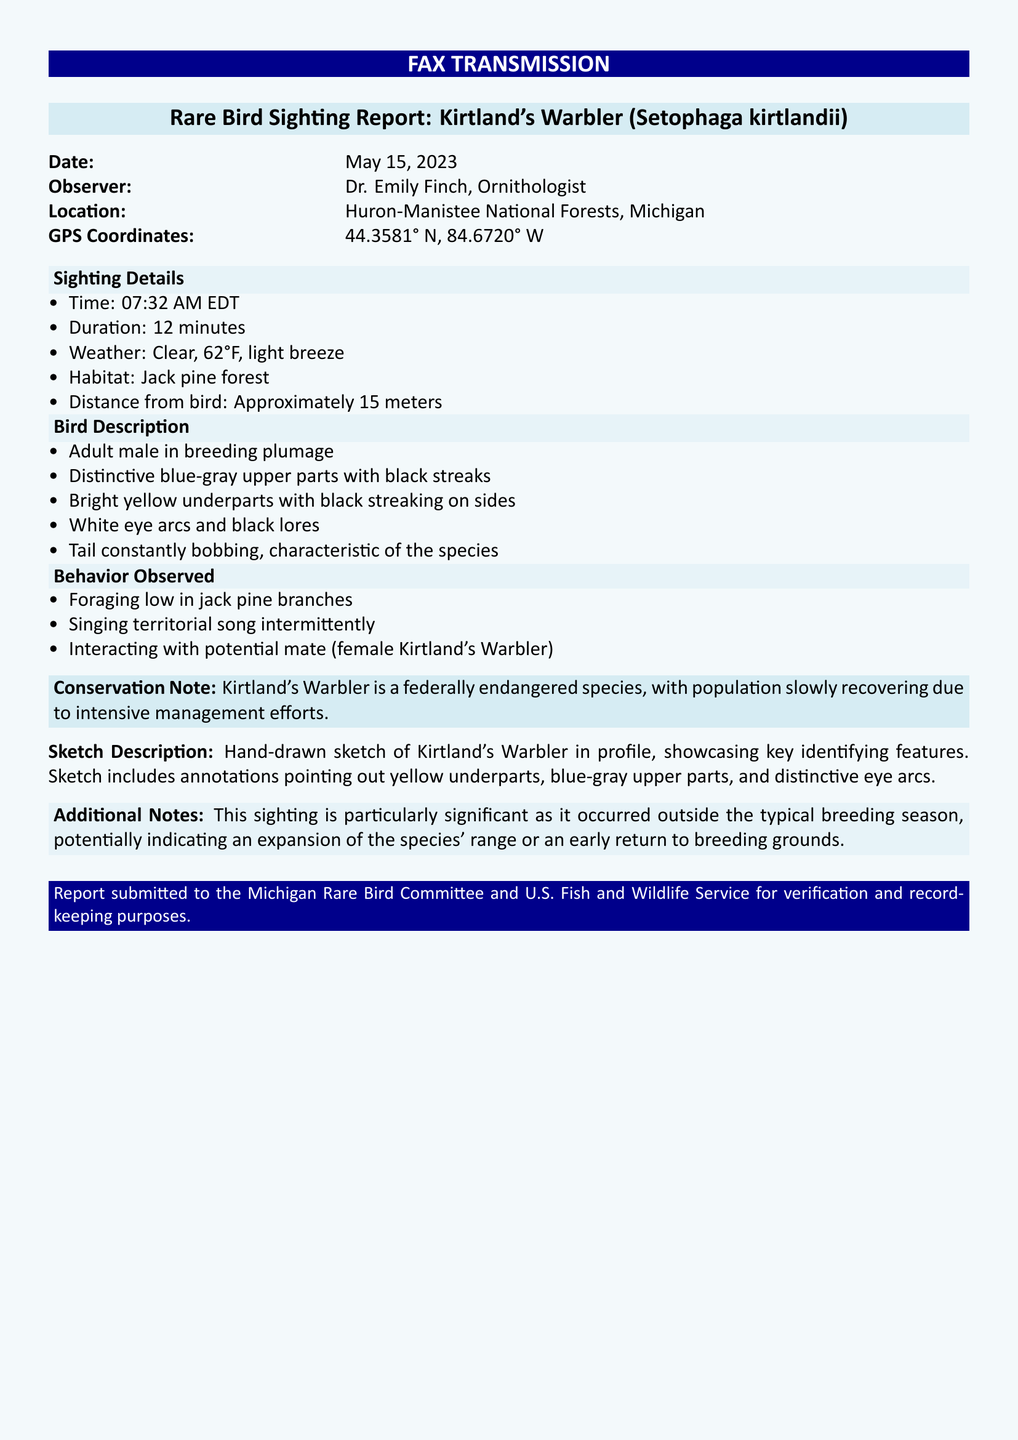What is the date of the sighting? The date is specified in the document under "Date:" as May 15, 2023.
Answer: May 15, 2023 Who was the observer? The observer's name is given as Dr. Emily Finch in the document.
Answer: Dr. Emily Finch What is the location of the sighting? The location details are provided under "Location:" as Huron-Manistee National Forests, Michigan.
Answer: Huron-Manistee National Forests, Michigan What is the time of the sighting? The time is mentioned under "Time:" as 07:32 AM EDT.
Answer: 07:32 AM EDT What is the weather condition during the sighting? The weather condition is given in the document as "Clear, 62°F, light breeze."
Answer: Clear, 62°F, light breeze How far was the observer from the bird? The distance from the bird is noted as "Approximately 15 meters."
Answer: Approximately 15 meters What species was observed? The species is identified as Kirtland's Warbler (Setophaga kirtlandii).
Answer: Kirtland's Warbler (Setophaga kirtlandii) What habitat was noted during the sighting? The habitat is described as "Jack pine forest" in the document.
Answer: Jack pine forest What unique behavior was observed in the bird? The document states that the bird was observed "singing territorial song intermittently."
Answer: Singing territorial song intermittently What conservation status does Kirtland's Warbler have? The conservation status noted in the document is "federally endangered."
Answer: Federally endangered 